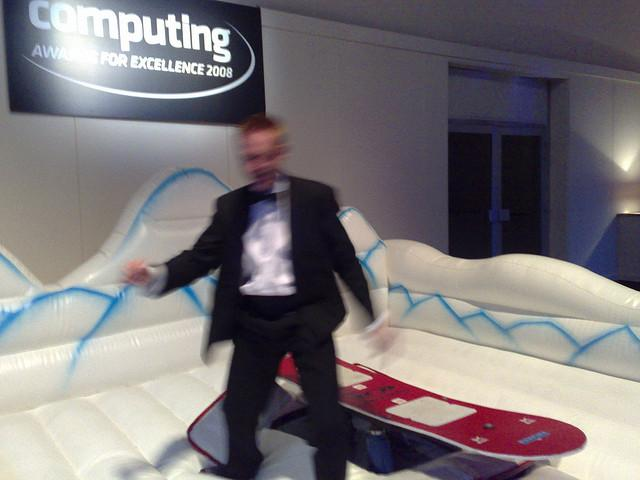The inflatable display is meant to simulate which winter sport?

Choices:
A) skiing
B) snowboarding
C) curling
D) ice skating snowboarding 